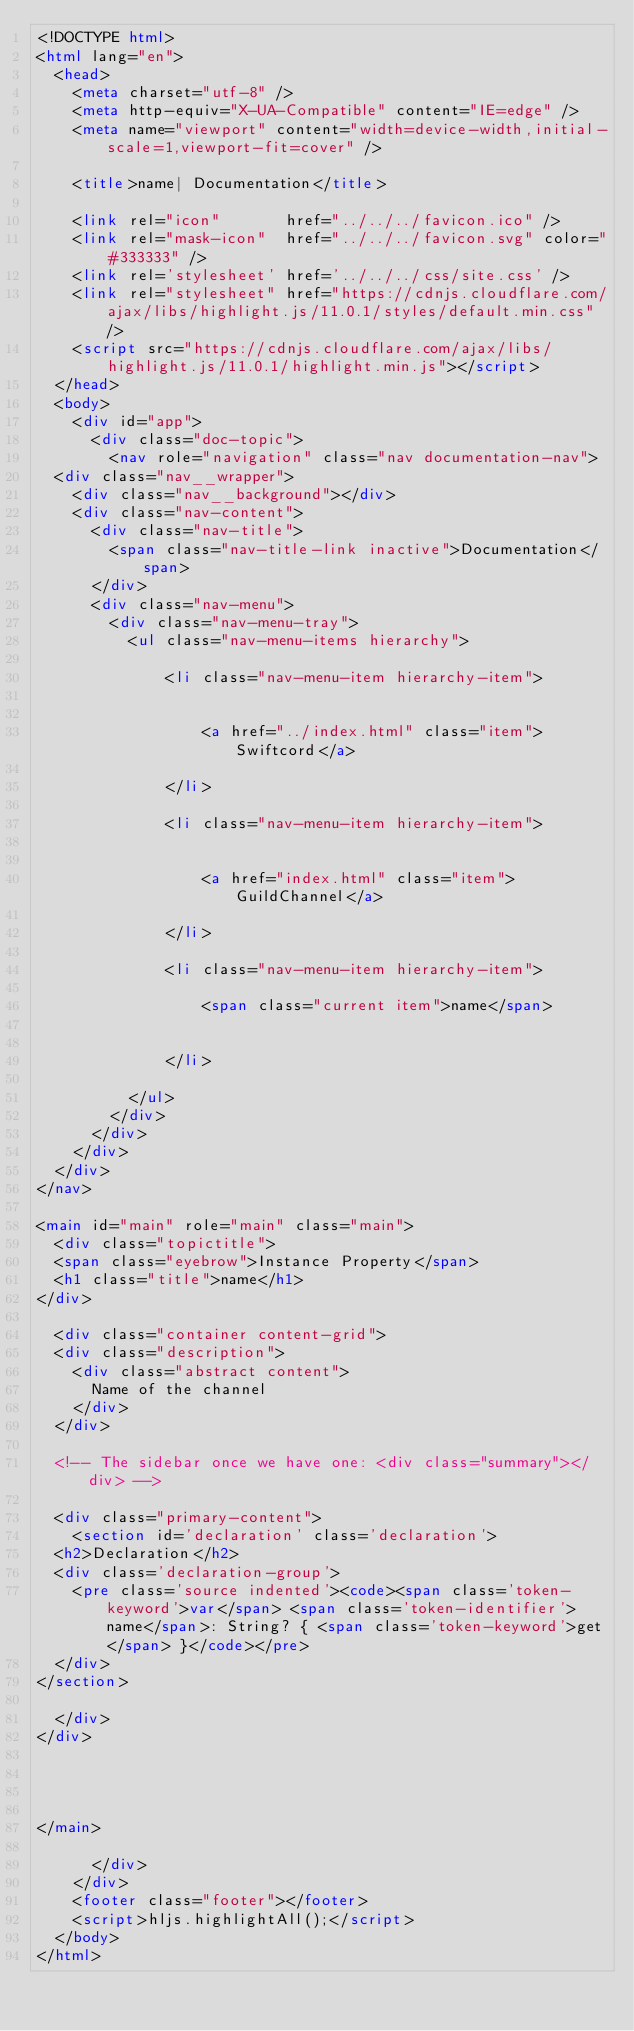<code> <loc_0><loc_0><loc_500><loc_500><_HTML_><!DOCTYPE html>
<html lang="en">
  <head>
    <meta charset="utf-8" />
    <meta http-equiv="X-UA-Compatible" content="IE=edge" />
    <meta name="viewport" content="width=device-width,initial-scale=1,viewport-fit=cover" />
    
    <title>name| Documentation</title>
    
    <link rel="icon"       href="../../../favicon.ico" />
    <link rel="mask-icon"  href="../../../favicon.svg" color="#333333" />
    <link rel='stylesheet' href='../../../css/site.css' />
    <link rel="stylesheet" href="https://cdnjs.cloudflare.com/ajax/libs/highlight.js/11.0.1/styles/default.min.css" />
    <script src="https://cdnjs.cloudflare.com/ajax/libs/highlight.js/11.0.1/highlight.min.js"></script>
  </head>
  <body>
    <div id="app">
      <div class="doc-topic">
        <nav role="navigation" class="nav documentation-nav">
  <div class="nav__wrapper">
    <div class="nav__background"></div>
    <div class="nav-content">
      <div class="nav-title">
        <span class="nav-title-link inactive">Documentation</span>
      </div>
      <div class="nav-menu">
        <div class="nav-menu-tray">
          <ul class="nav-menu-items hierarchy">
            
              <li class="nav-menu-item hierarchy-item">
                
                
                  <a href="../index.html" class="item">Swiftcord</a>
                
              </li>
            
              <li class="nav-menu-item hierarchy-item">
                
                
                  <a href="index.html" class="item">GuildChannel</a>
                
              </li>
            
              <li class="nav-menu-item hierarchy-item">
                
                  <span class="current item">name</span>
                
                
              </li>
            
          </ul>
        </div>
      </div>
    </div>
  </div>
</nav>

<main id="main" role="main" class="main">
  <div class="topictitle">
  <span class="eyebrow">Instance Property</span>
  <h1 class="title">name</h1>
</div>

  <div class="container content-grid">
  <div class="description">
    <div class="abstract content">
      Name of the channel
    </div>
  </div>
  
  <!-- The sidebar once we have one: <div class="summary"></div> -->
  
  <div class="primary-content">
    <section id='declaration' class='declaration'>
  <h2>Declaration</h2>
  <div class='declaration-group'>
    <pre class='source indented'><code><span class='token-keyword'>var</span> <span class='token-identifier'>name</span>: String? { <span class='token-keyword'>get</span> }</code></pre>
  </div>
</section>

  </div>
</div>

  
  
  
</main>

      </div>
    </div>
    <footer class="footer"></footer>
    <script>hljs.highlightAll();</script>
  </body>
</html>
</code> 